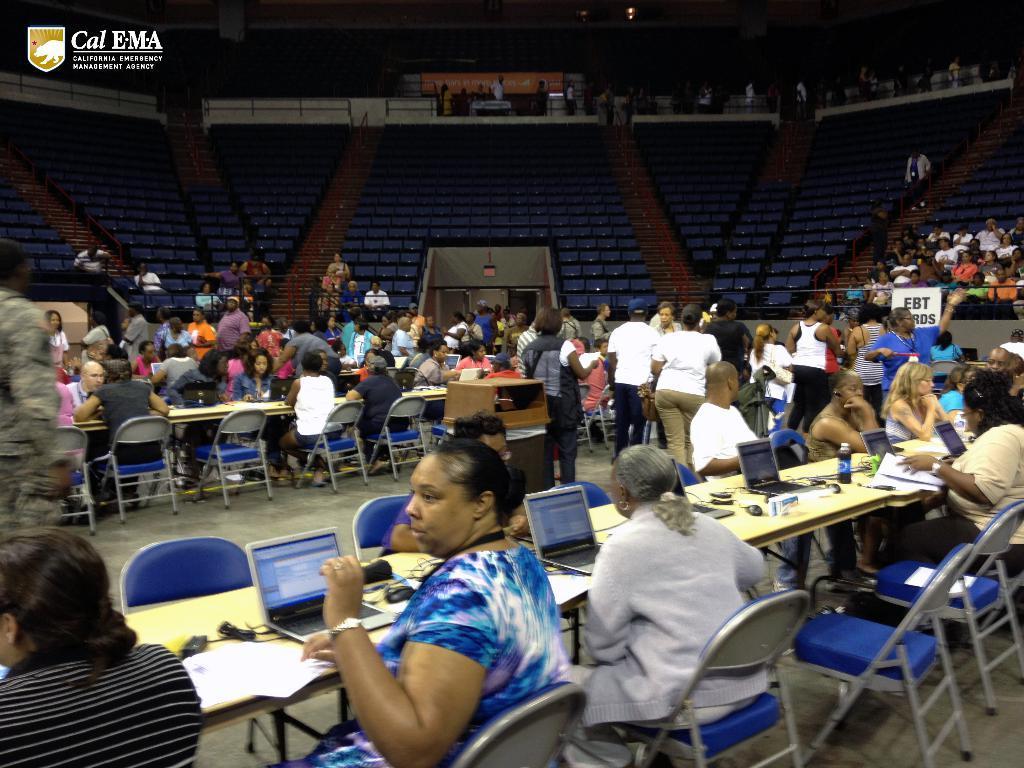Could you give a brief overview of what you see in this image? Most of the persons are sitting on a chair. On this table there are laptops, bottle and papers. 